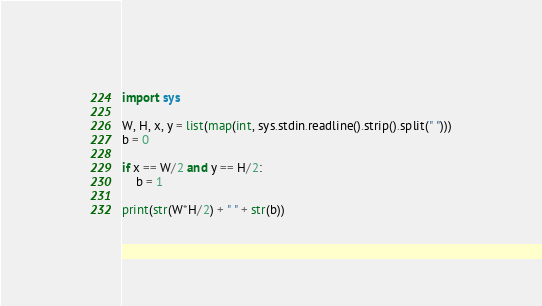Convert code to text. <code><loc_0><loc_0><loc_500><loc_500><_Python_>import sys

W, H, x, y = list(map(int, sys.stdin.readline().strip().split(" ")))
b = 0

if x == W/2 and y == H/2:
    b = 1

print(str(W*H/2) + " " + str(b))
</code> 